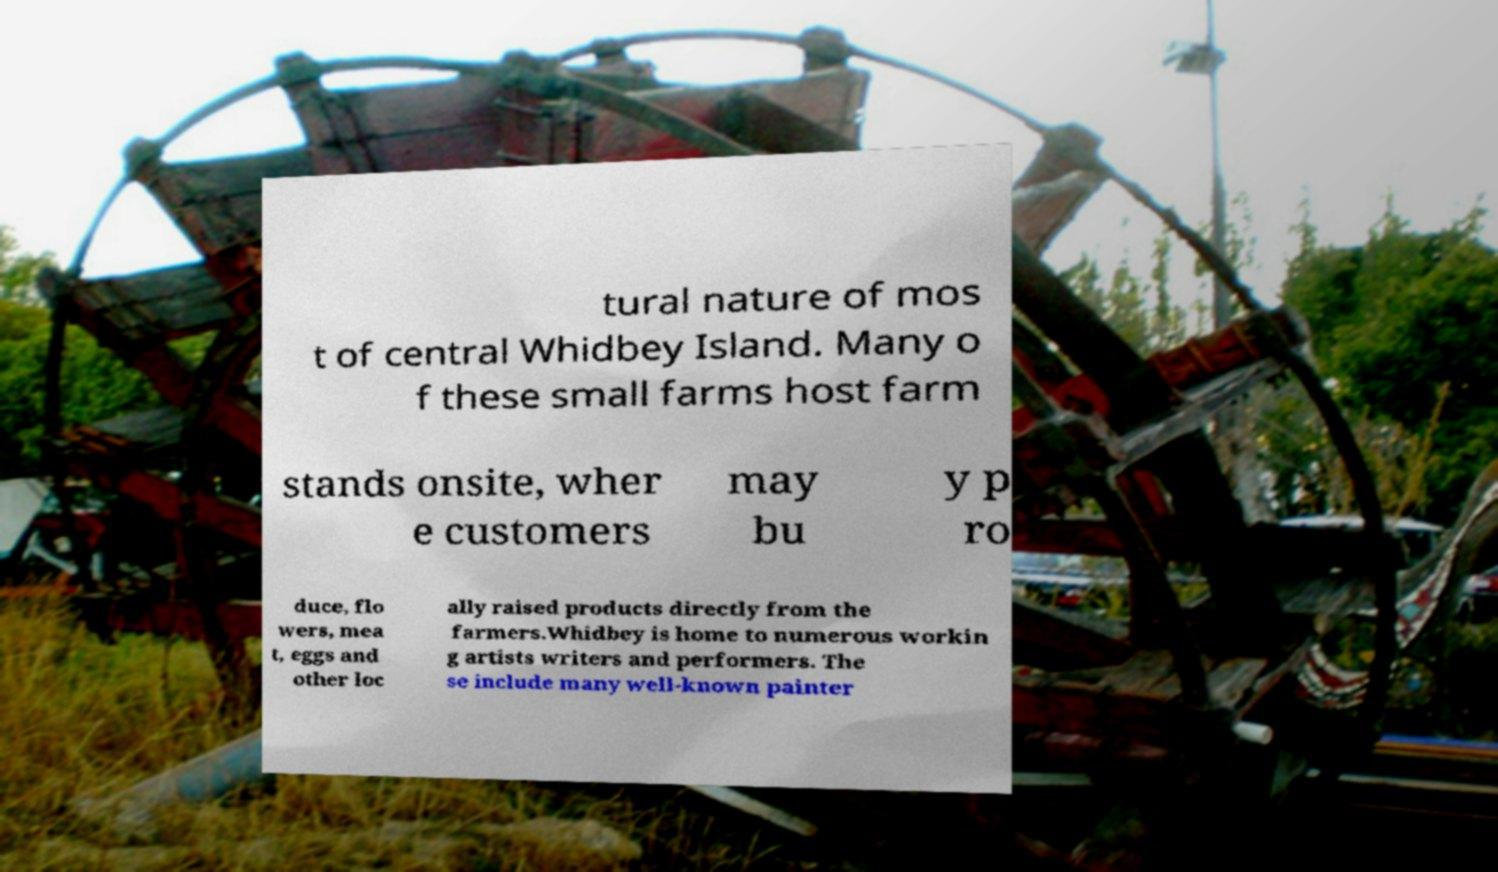I need the written content from this picture converted into text. Can you do that? tural nature of mos t of central Whidbey Island. Many o f these small farms host farm stands onsite, wher e customers may bu y p ro duce, flo wers, mea t, eggs and other loc ally raised products directly from the farmers.Whidbey is home to numerous workin g artists writers and performers. The se include many well-known painter 